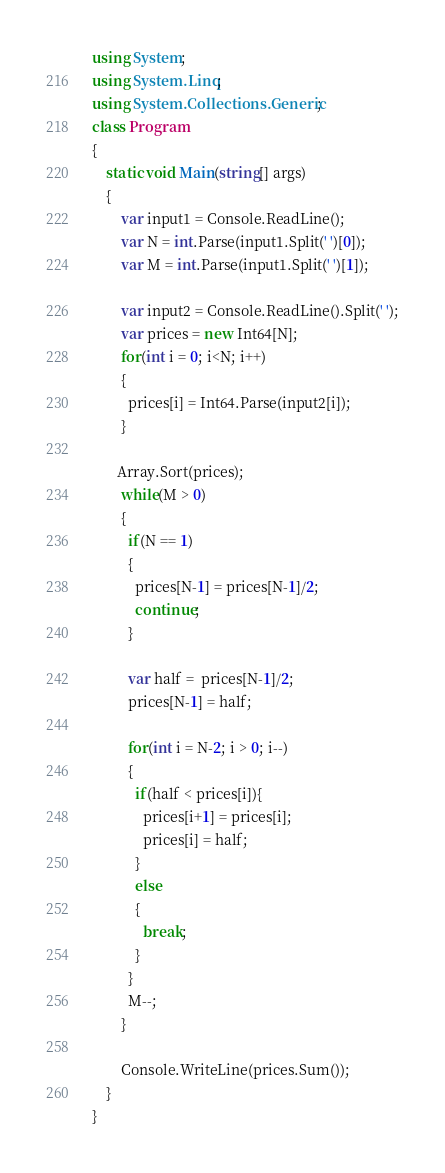<code> <loc_0><loc_0><loc_500><loc_500><_C#_>using System;
using System.Linq;
using System.Collections.Generic;
class Program
{
	static void Main(string[] args)
	{      
        var input1 = Console.ReadLine();
        var N = int.Parse(input1.Split(' ')[0]);
        var M = int.Parse(input1.Split(' ')[1]);
       
        var input2 = Console.ReadLine().Split(' ');
        var prices = new Int64[N];
        for(int i = 0; i<N; i++)
        {
          prices[i] = Int64.Parse(input2[i]);
        }
                 
       Array.Sort(prices);
      	while(M > 0)
        {
          if(N == 1)
          {
            prices[N-1] = prices[N-1]/2;
            continue;
          }
         
          var half =  prices[N-1]/2;
          prices[N-1] = half;
          
          for(int i = N-2; i > 0; i--)
          {           
            if(half < prices[i]){
              prices[i+1] = prices[i];
              prices[i] = half;
            }
            else
            {
              break;
            }
          }
          M--;
        }
      
     	Console.WriteLine(prices.Sum());
	}
}</code> 